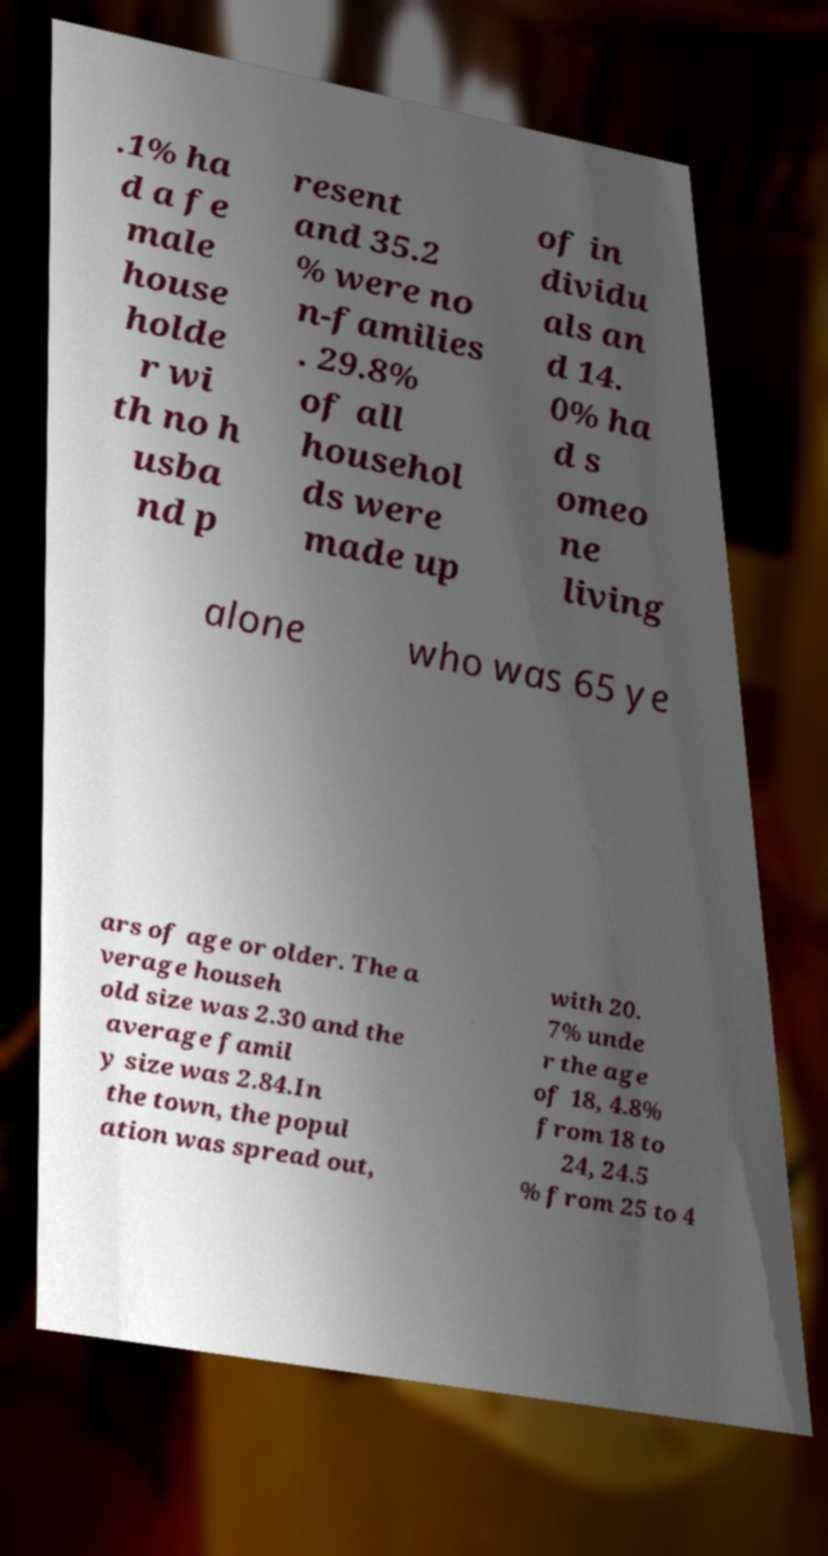Could you assist in decoding the text presented in this image and type it out clearly? .1% ha d a fe male house holde r wi th no h usba nd p resent and 35.2 % were no n-families . 29.8% of all househol ds were made up of in dividu als an d 14. 0% ha d s omeo ne living alone who was 65 ye ars of age or older. The a verage househ old size was 2.30 and the average famil y size was 2.84.In the town, the popul ation was spread out, with 20. 7% unde r the age of 18, 4.8% from 18 to 24, 24.5 % from 25 to 4 